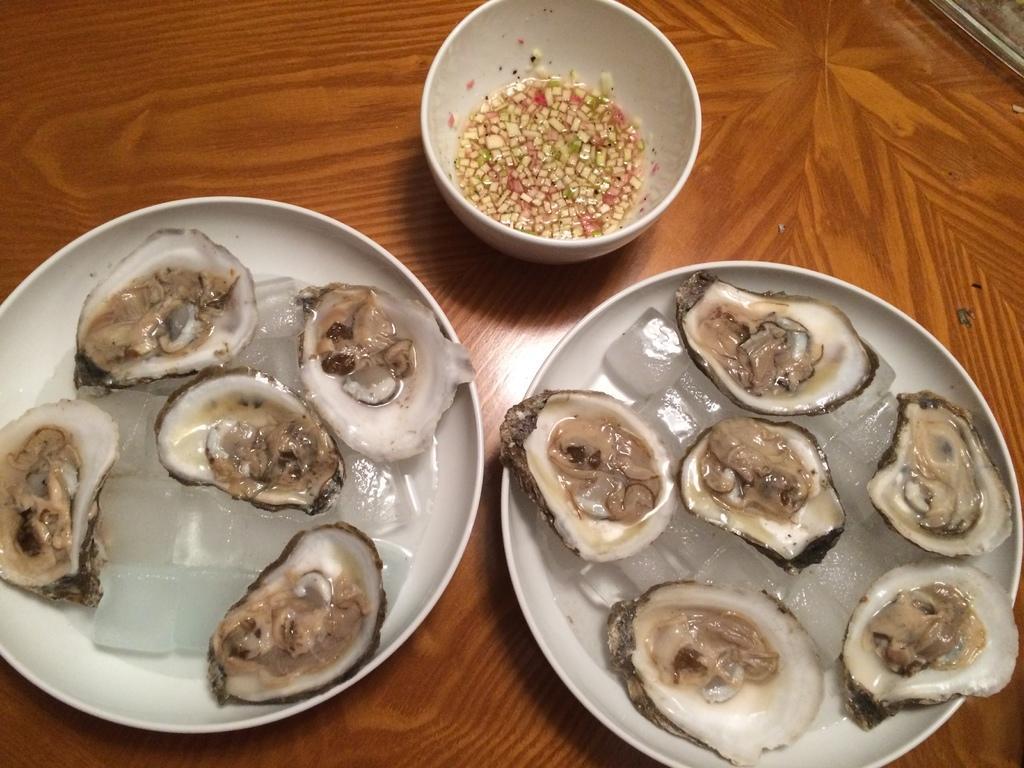Describe this image in one or two sentences. In this image, we can see some food items in plates are placed on the wooden surface. We can also see some ice. 